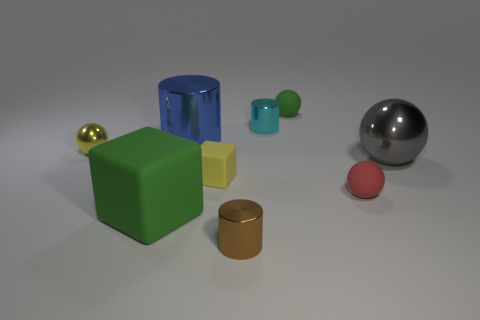Subtract 1 balls. How many balls are left? 3 Subtract all purple cylinders. Subtract all purple balls. How many cylinders are left? 3 Add 1 tiny metallic cylinders. How many objects exist? 10 Subtract all blocks. How many objects are left? 7 Add 6 big gray spheres. How many big gray spheres are left? 7 Add 3 brown rubber cubes. How many brown rubber cubes exist? 3 Subtract 1 brown cylinders. How many objects are left? 8 Subtract all big yellow rubber objects. Subtract all tiny brown cylinders. How many objects are left? 8 